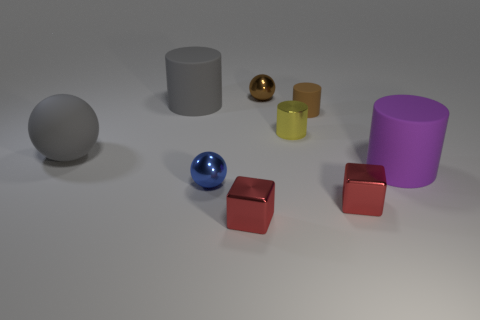There is a tiny ball that is the same color as the small rubber cylinder; what is its material?
Provide a short and direct response. Metal. What material is the thing to the left of the big gray rubber thing behind the small yellow metal object made of?
Provide a short and direct response. Rubber. There is a brown thing that is the same shape as the big purple rubber object; what size is it?
Keep it short and to the point. Small. Do the metallic sphere that is behind the purple matte cylinder and the tiny matte object have the same color?
Give a very brief answer. Yes. Are there fewer purple things than small purple matte spheres?
Provide a short and direct response. No. What number of other objects are the same color as the large ball?
Ensure brevity in your answer.  1. Are the tiny red thing on the right side of the small brown matte cylinder and the tiny brown cylinder made of the same material?
Give a very brief answer. No. What is the material of the large gray thing behind the yellow cylinder?
Provide a short and direct response. Rubber. What is the size of the ball in front of the matte object on the right side of the tiny rubber object?
Your response must be concise. Small. Are there any purple cylinders that have the same material as the big purple object?
Provide a short and direct response. No. 